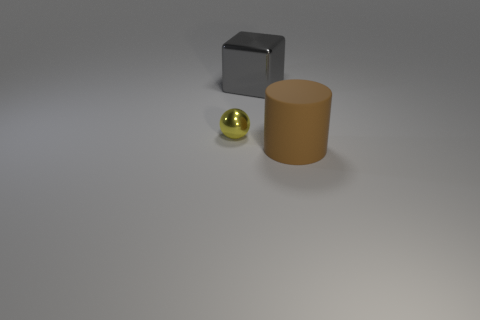What material is the thing that is both in front of the big metal cube and on the right side of the yellow ball?
Provide a short and direct response. Rubber. Do the object that is to the right of the gray object and the large shiny thing have the same size?
Provide a short and direct response. Yes. Is there any other thing that has the same size as the yellow ball?
Your answer should be compact. No. Is the number of balls in front of the large matte thing greater than the number of gray blocks behind the large gray cube?
Your answer should be compact. No. There is a thing that is on the left side of the metallic thing behind the object that is left of the big cube; what is its color?
Your answer should be very brief. Yellow. How many other objects are there of the same color as the tiny metal ball?
Your answer should be compact. 0. What number of objects are gray things or gray shiny balls?
Your answer should be compact. 1. How many things are tiny shiny spheres or big objects behind the big brown rubber cylinder?
Your answer should be very brief. 2. Are the small yellow thing and the big cylinder made of the same material?
Ensure brevity in your answer.  No. What number of other objects are the same material as the tiny thing?
Provide a succinct answer. 1. 